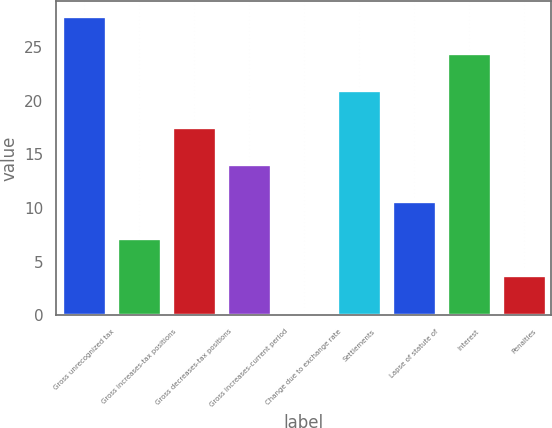<chart> <loc_0><loc_0><loc_500><loc_500><bar_chart><fcel>Gross unrecognized tax<fcel>Gross increases-tax positions<fcel>Gross decreases-tax positions<fcel>Gross increases-current period<fcel>Change due to exchange rate<fcel>Settlements<fcel>Lapse of statute of<fcel>Interest<fcel>Penalties<nl><fcel>27.9<fcel>7.2<fcel>17.55<fcel>14.1<fcel>0.3<fcel>21<fcel>10.65<fcel>24.45<fcel>3.75<nl></chart> 